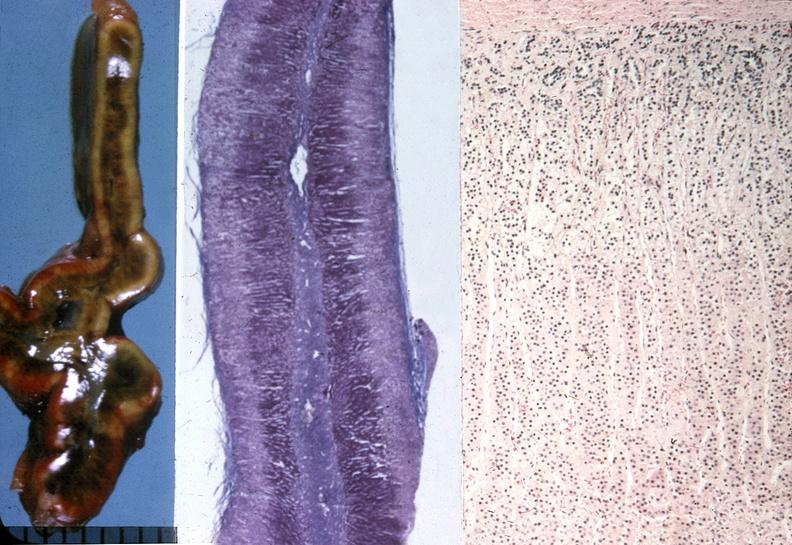s abdomen present?
Answer the question using a single word or phrase. No 